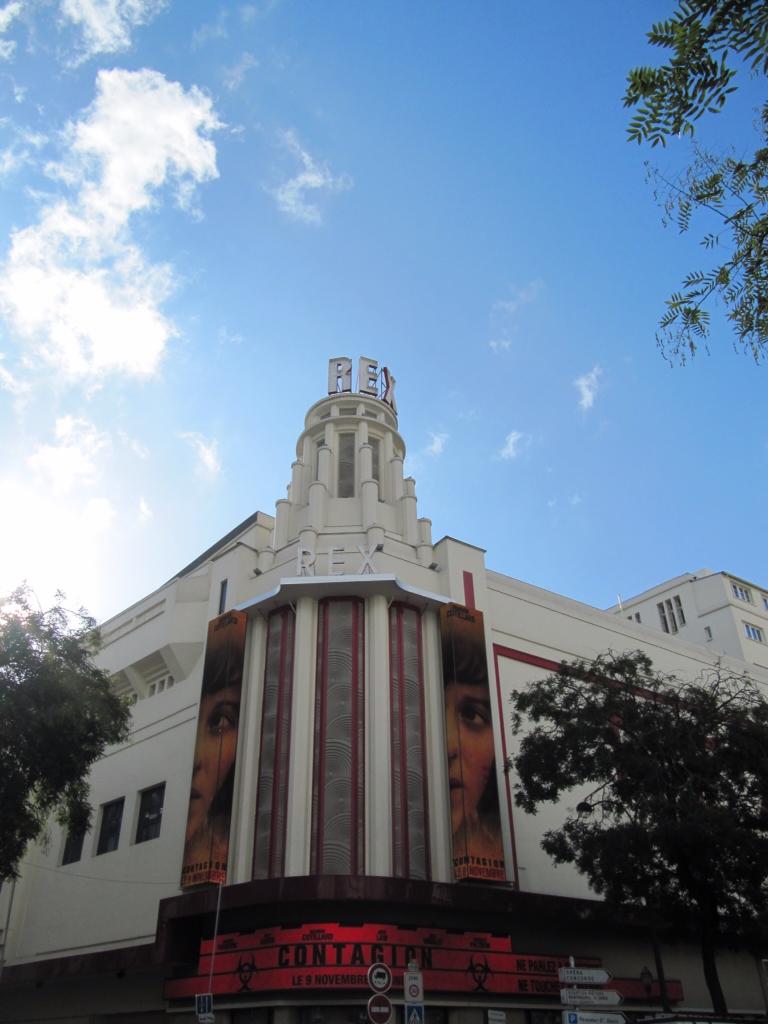What movie is being advertised here?
Give a very brief answer. Unanswerable. Phone is display?
Your answer should be very brief. Unanswerable. 